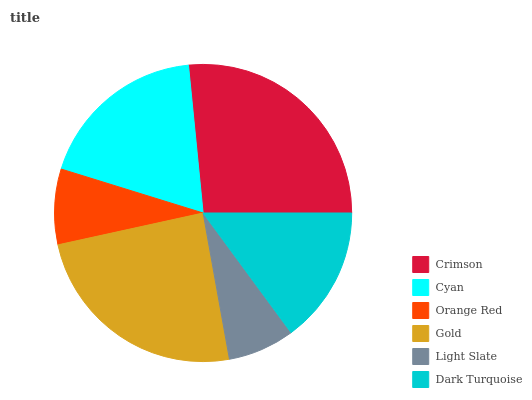Is Light Slate the minimum?
Answer yes or no. Yes. Is Crimson the maximum?
Answer yes or no. Yes. Is Cyan the minimum?
Answer yes or no. No. Is Cyan the maximum?
Answer yes or no. No. Is Crimson greater than Cyan?
Answer yes or no. Yes. Is Cyan less than Crimson?
Answer yes or no. Yes. Is Cyan greater than Crimson?
Answer yes or no. No. Is Crimson less than Cyan?
Answer yes or no. No. Is Cyan the high median?
Answer yes or no. Yes. Is Dark Turquoise the low median?
Answer yes or no. Yes. Is Dark Turquoise the high median?
Answer yes or no. No. Is Gold the low median?
Answer yes or no. No. 